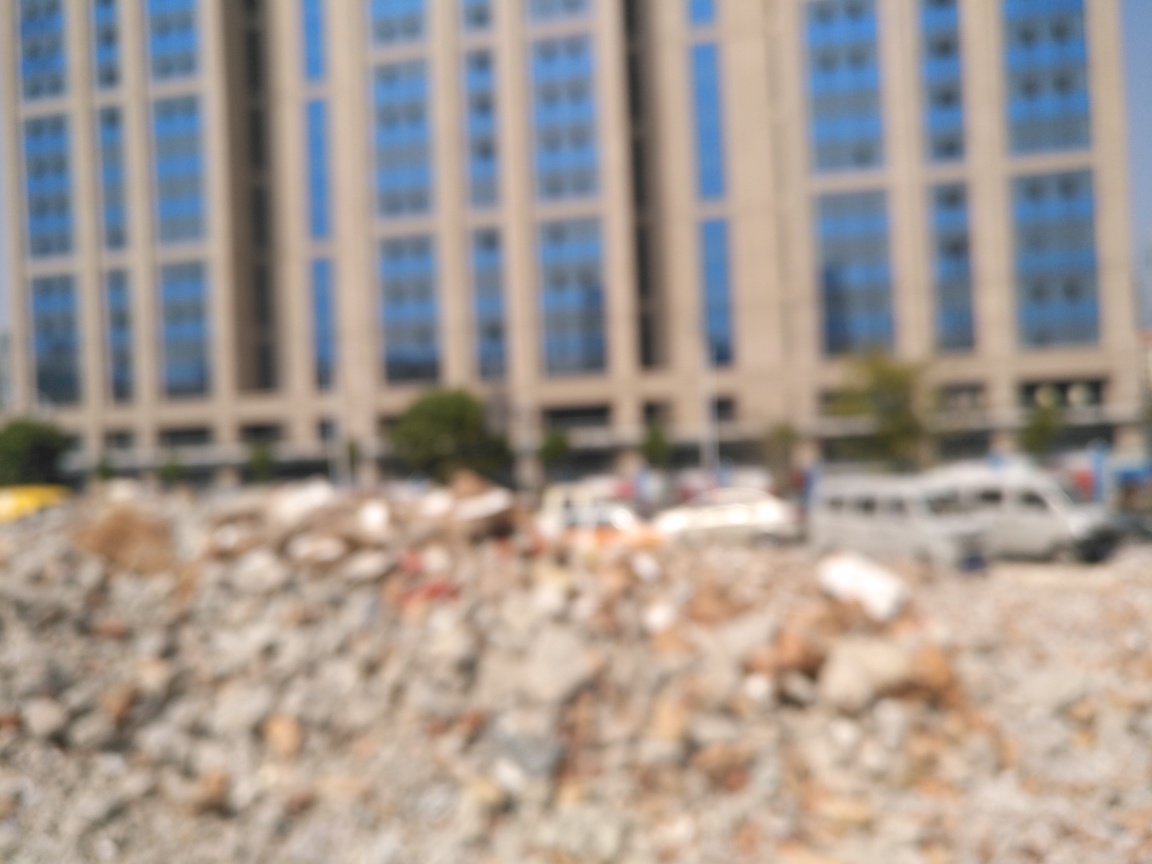Can you describe the overall setting of the image despite the blurriness? While specific details are not discernible due to the blurriness, the image seems to depict an urban environment. A large building with multiple windows can be seen in the background, and there appears to be a foreground of uneven terrain that may suggest a construction site or demolished area. 